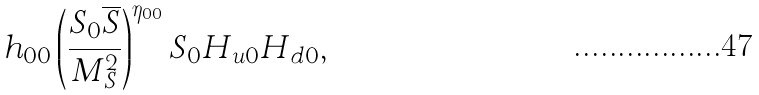Convert formula to latex. <formula><loc_0><loc_0><loc_500><loc_500>h _ { 0 0 } \left ( \frac { S _ { 0 } { \overline { S } } } { M _ { S } ^ { 2 } } \right ) ^ { \eta _ { 0 0 } } S _ { 0 } H _ { u 0 } H _ { d 0 } ,</formula> 